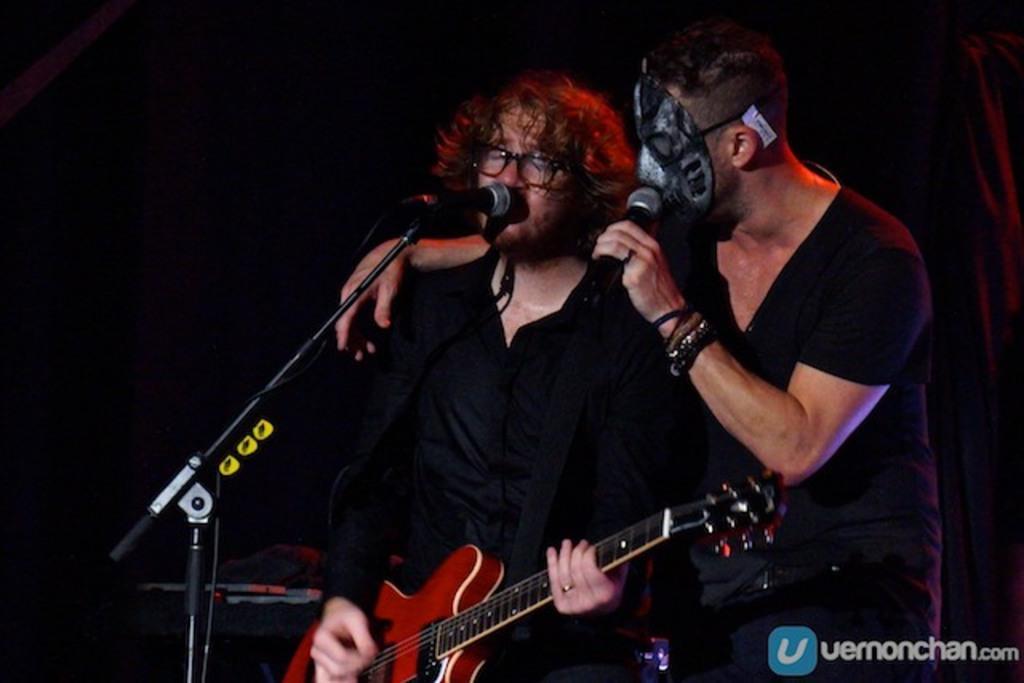In one or two sentences, can you explain what this image depicts? 2 people are standing wearing black shirts and singing. the person at the right is wearing the mask. the person at the left is playing red guitar. there is a microphone present in front of them. 